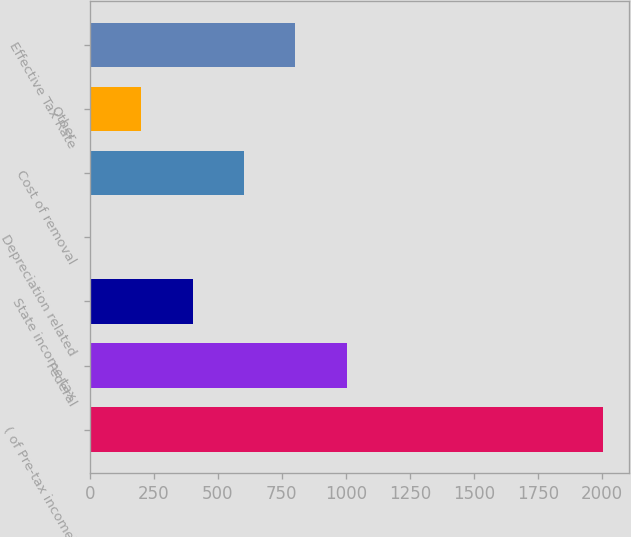Convert chart to OTSL. <chart><loc_0><loc_0><loc_500><loc_500><bar_chart><fcel>( of Pre-tax income)<fcel>Federal<fcel>State income tax<fcel>Depreciation related<fcel>Cost of removal<fcel>Other<fcel>Effective Tax Rate<nl><fcel>2006<fcel>1003.5<fcel>402<fcel>1<fcel>602.5<fcel>201.5<fcel>803<nl></chart> 